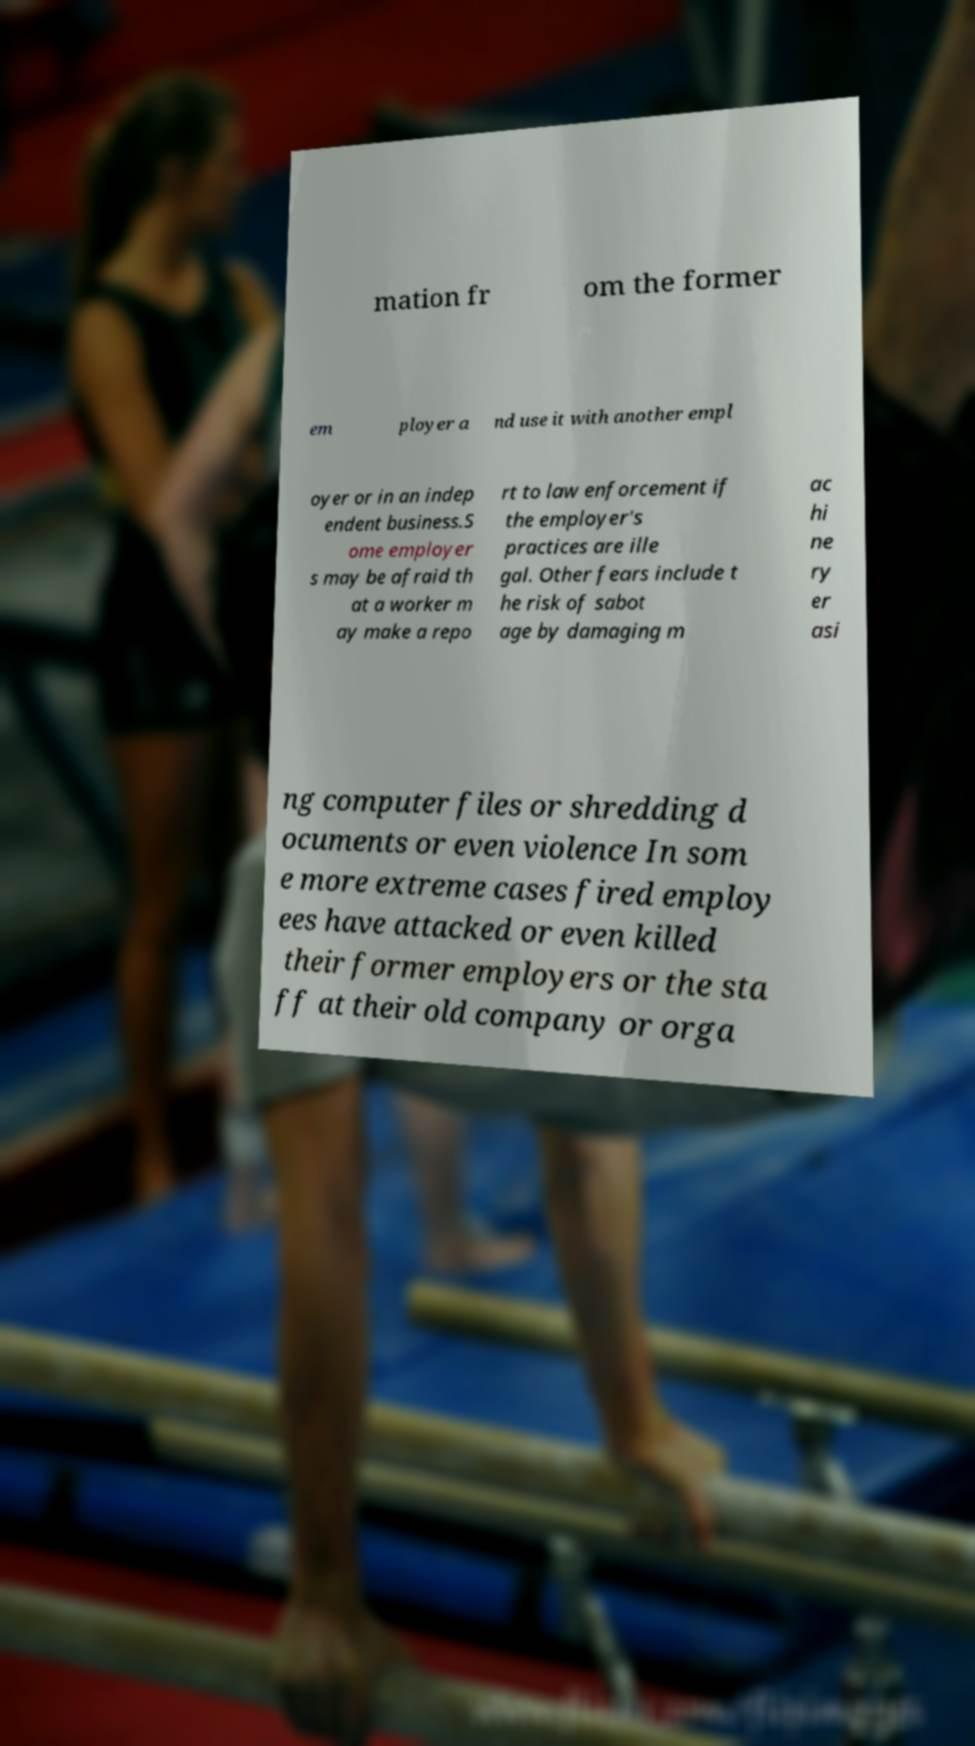Please read and relay the text visible in this image. What does it say? mation fr om the former em ployer a nd use it with another empl oyer or in an indep endent business.S ome employer s may be afraid th at a worker m ay make a repo rt to law enforcement if the employer's practices are ille gal. Other fears include t he risk of sabot age by damaging m ac hi ne ry er asi ng computer files or shredding d ocuments or even violence In som e more extreme cases fired employ ees have attacked or even killed their former employers or the sta ff at their old company or orga 